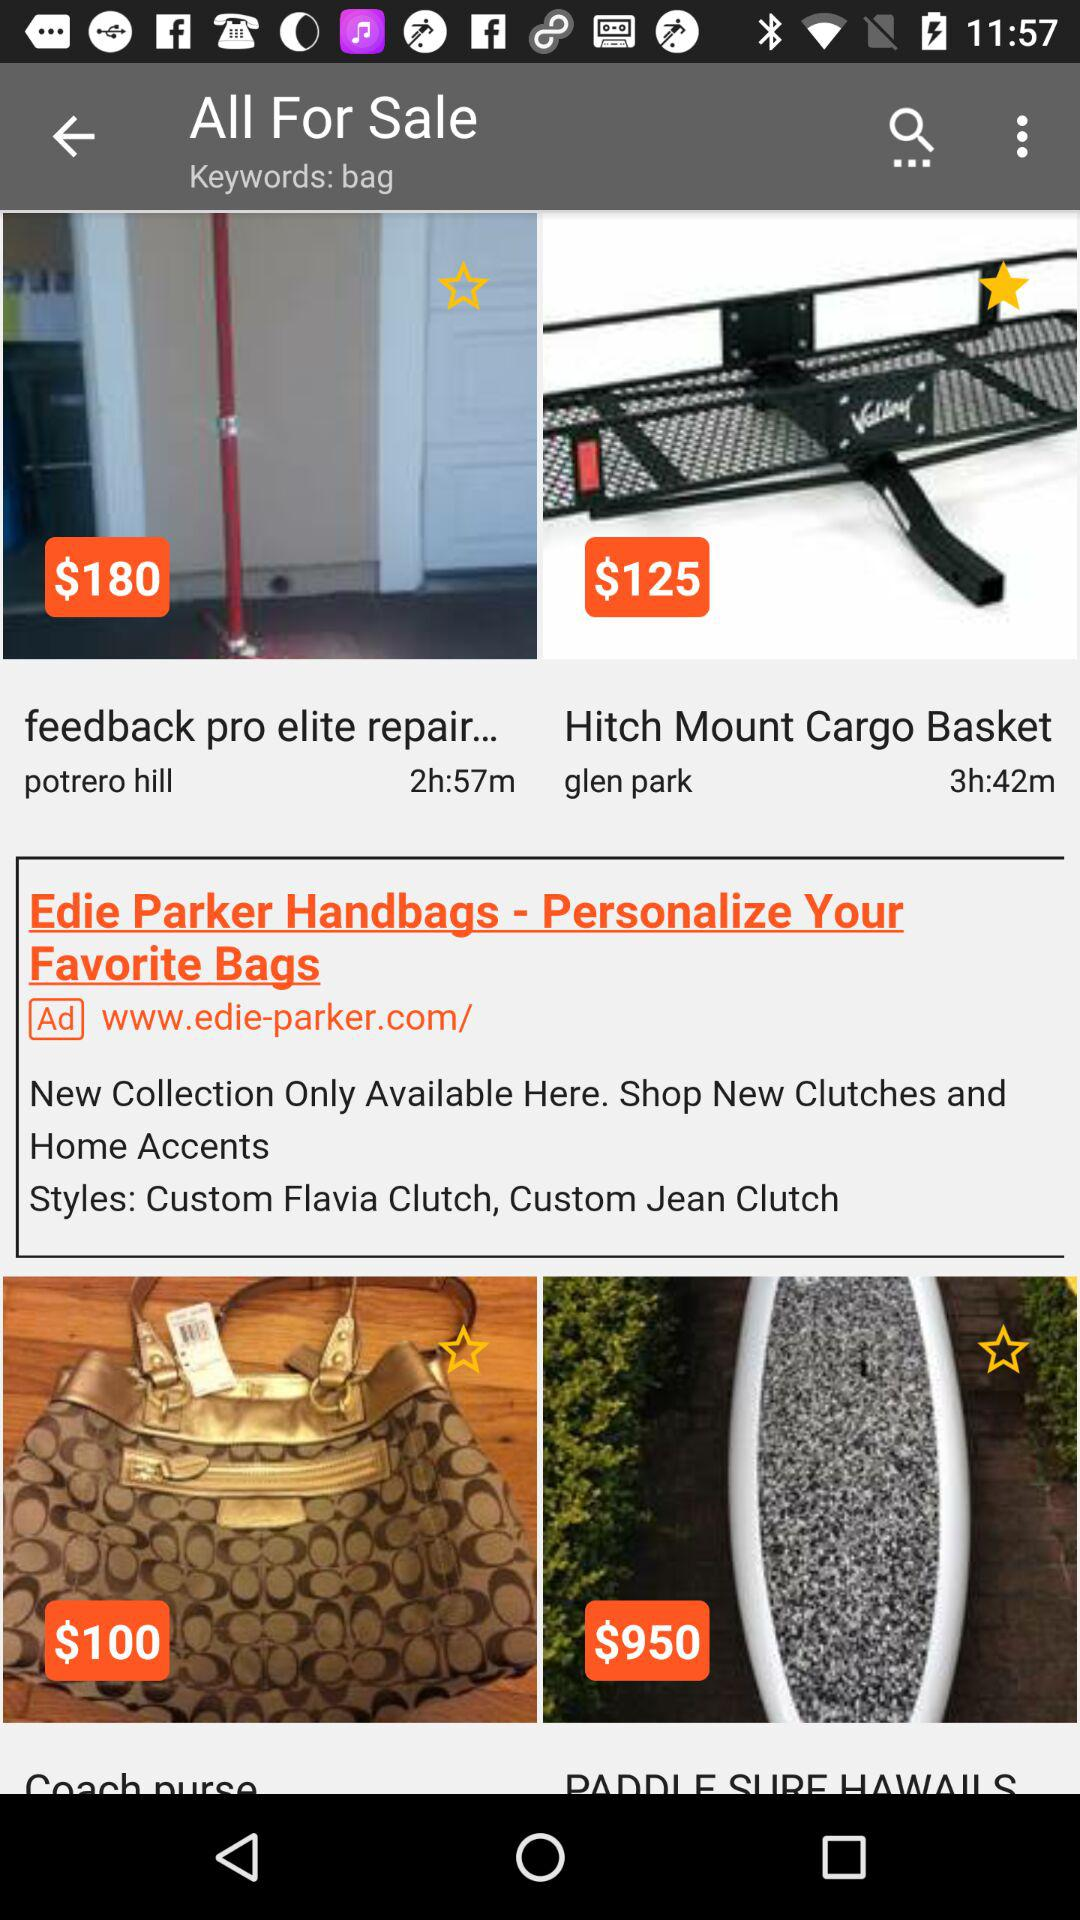When will the sales end for the cargo basket? The sales end in 3 hours and 42 minutes. 